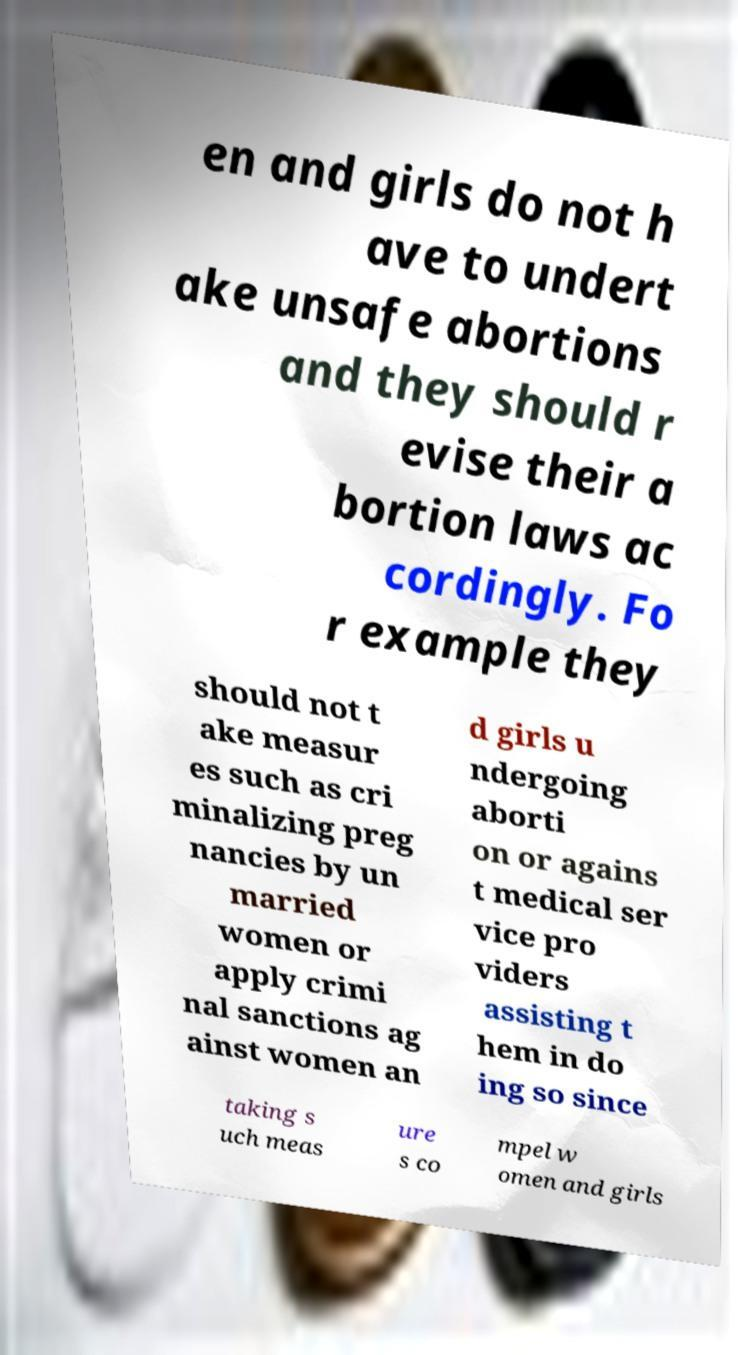Could you assist in decoding the text presented in this image and type it out clearly? en and girls do not h ave to undert ake unsafe abortions and they should r evise their a bortion laws ac cordingly. Fo r example they should not t ake measur es such as cri minalizing preg nancies by un married women or apply crimi nal sanctions ag ainst women an d girls u ndergoing aborti on or agains t medical ser vice pro viders assisting t hem in do ing so since taking s uch meas ure s co mpel w omen and girls 